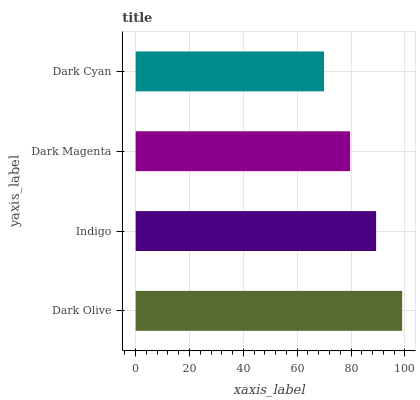Is Dark Cyan the minimum?
Answer yes or no. Yes. Is Dark Olive the maximum?
Answer yes or no. Yes. Is Indigo the minimum?
Answer yes or no. No. Is Indigo the maximum?
Answer yes or no. No. Is Dark Olive greater than Indigo?
Answer yes or no. Yes. Is Indigo less than Dark Olive?
Answer yes or no. Yes. Is Indigo greater than Dark Olive?
Answer yes or no. No. Is Dark Olive less than Indigo?
Answer yes or no. No. Is Indigo the high median?
Answer yes or no. Yes. Is Dark Magenta the low median?
Answer yes or no. Yes. Is Dark Magenta the high median?
Answer yes or no. No. Is Indigo the low median?
Answer yes or no. No. 